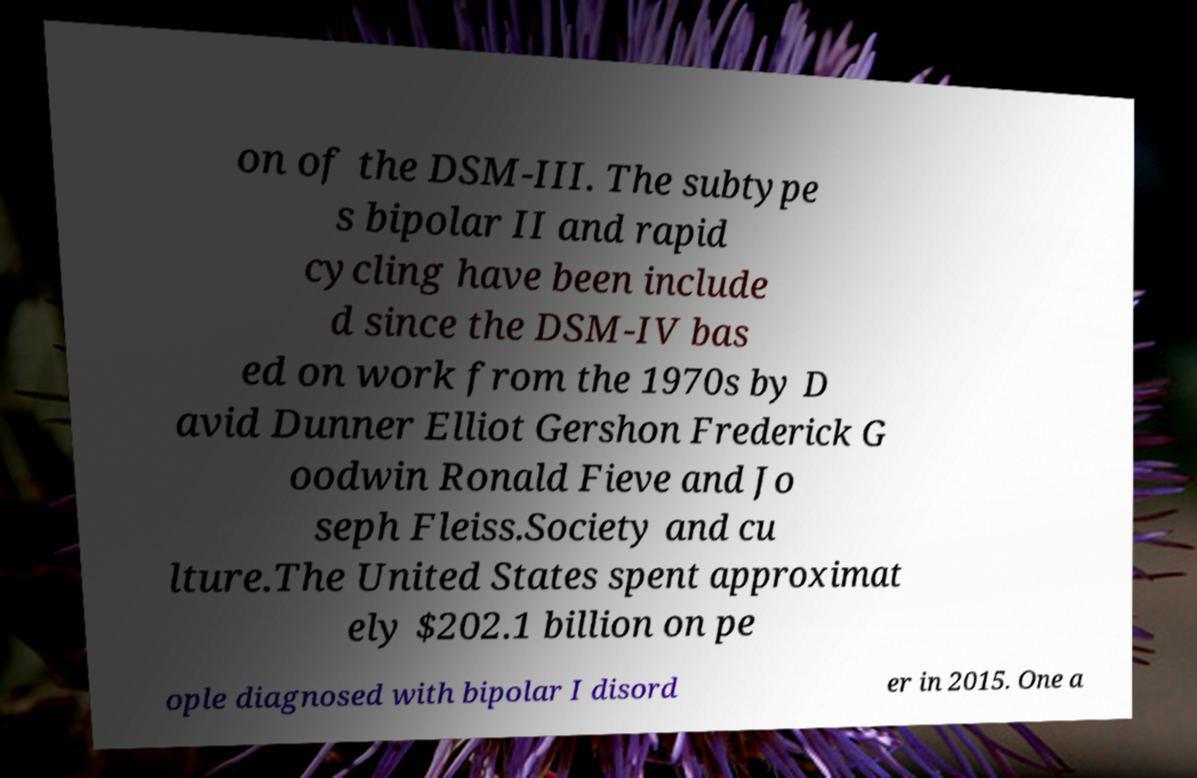Could you extract and type out the text from this image? on of the DSM-III. The subtype s bipolar II and rapid cycling have been include d since the DSM-IV bas ed on work from the 1970s by D avid Dunner Elliot Gershon Frederick G oodwin Ronald Fieve and Jo seph Fleiss.Society and cu lture.The United States spent approximat ely $202.1 billion on pe ople diagnosed with bipolar I disord er in 2015. One a 